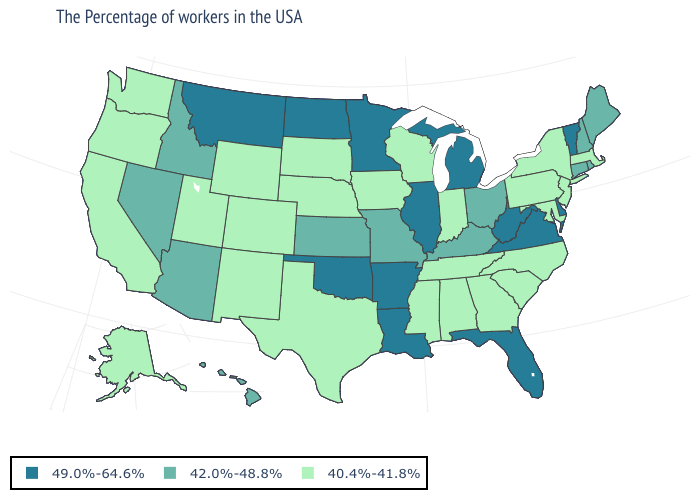What is the value of Kansas?
Keep it brief. 42.0%-48.8%. What is the lowest value in the USA?
Concise answer only. 40.4%-41.8%. Does the first symbol in the legend represent the smallest category?
Short answer required. No. What is the highest value in the USA?
Be succinct. 49.0%-64.6%. How many symbols are there in the legend?
Keep it brief. 3. Does Oregon have the same value as Pennsylvania?
Give a very brief answer. Yes. What is the value of South Dakota?
Short answer required. 40.4%-41.8%. Does Wyoming have a higher value than Illinois?
Answer briefly. No. What is the lowest value in the USA?
Concise answer only. 40.4%-41.8%. Which states hav the highest value in the South?
Short answer required. Delaware, Virginia, West Virginia, Florida, Louisiana, Arkansas, Oklahoma. Name the states that have a value in the range 49.0%-64.6%?
Keep it brief. Vermont, Delaware, Virginia, West Virginia, Florida, Michigan, Illinois, Louisiana, Arkansas, Minnesota, Oklahoma, North Dakota, Montana. What is the lowest value in the MidWest?
Concise answer only. 40.4%-41.8%. What is the value of Illinois?
Write a very short answer. 49.0%-64.6%. Among the states that border Iowa , which have the lowest value?
Concise answer only. Wisconsin, Nebraska, South Dakota. What is the highest value in states that border Vermont?
Quick response, please. 42.0%-48.8%. 